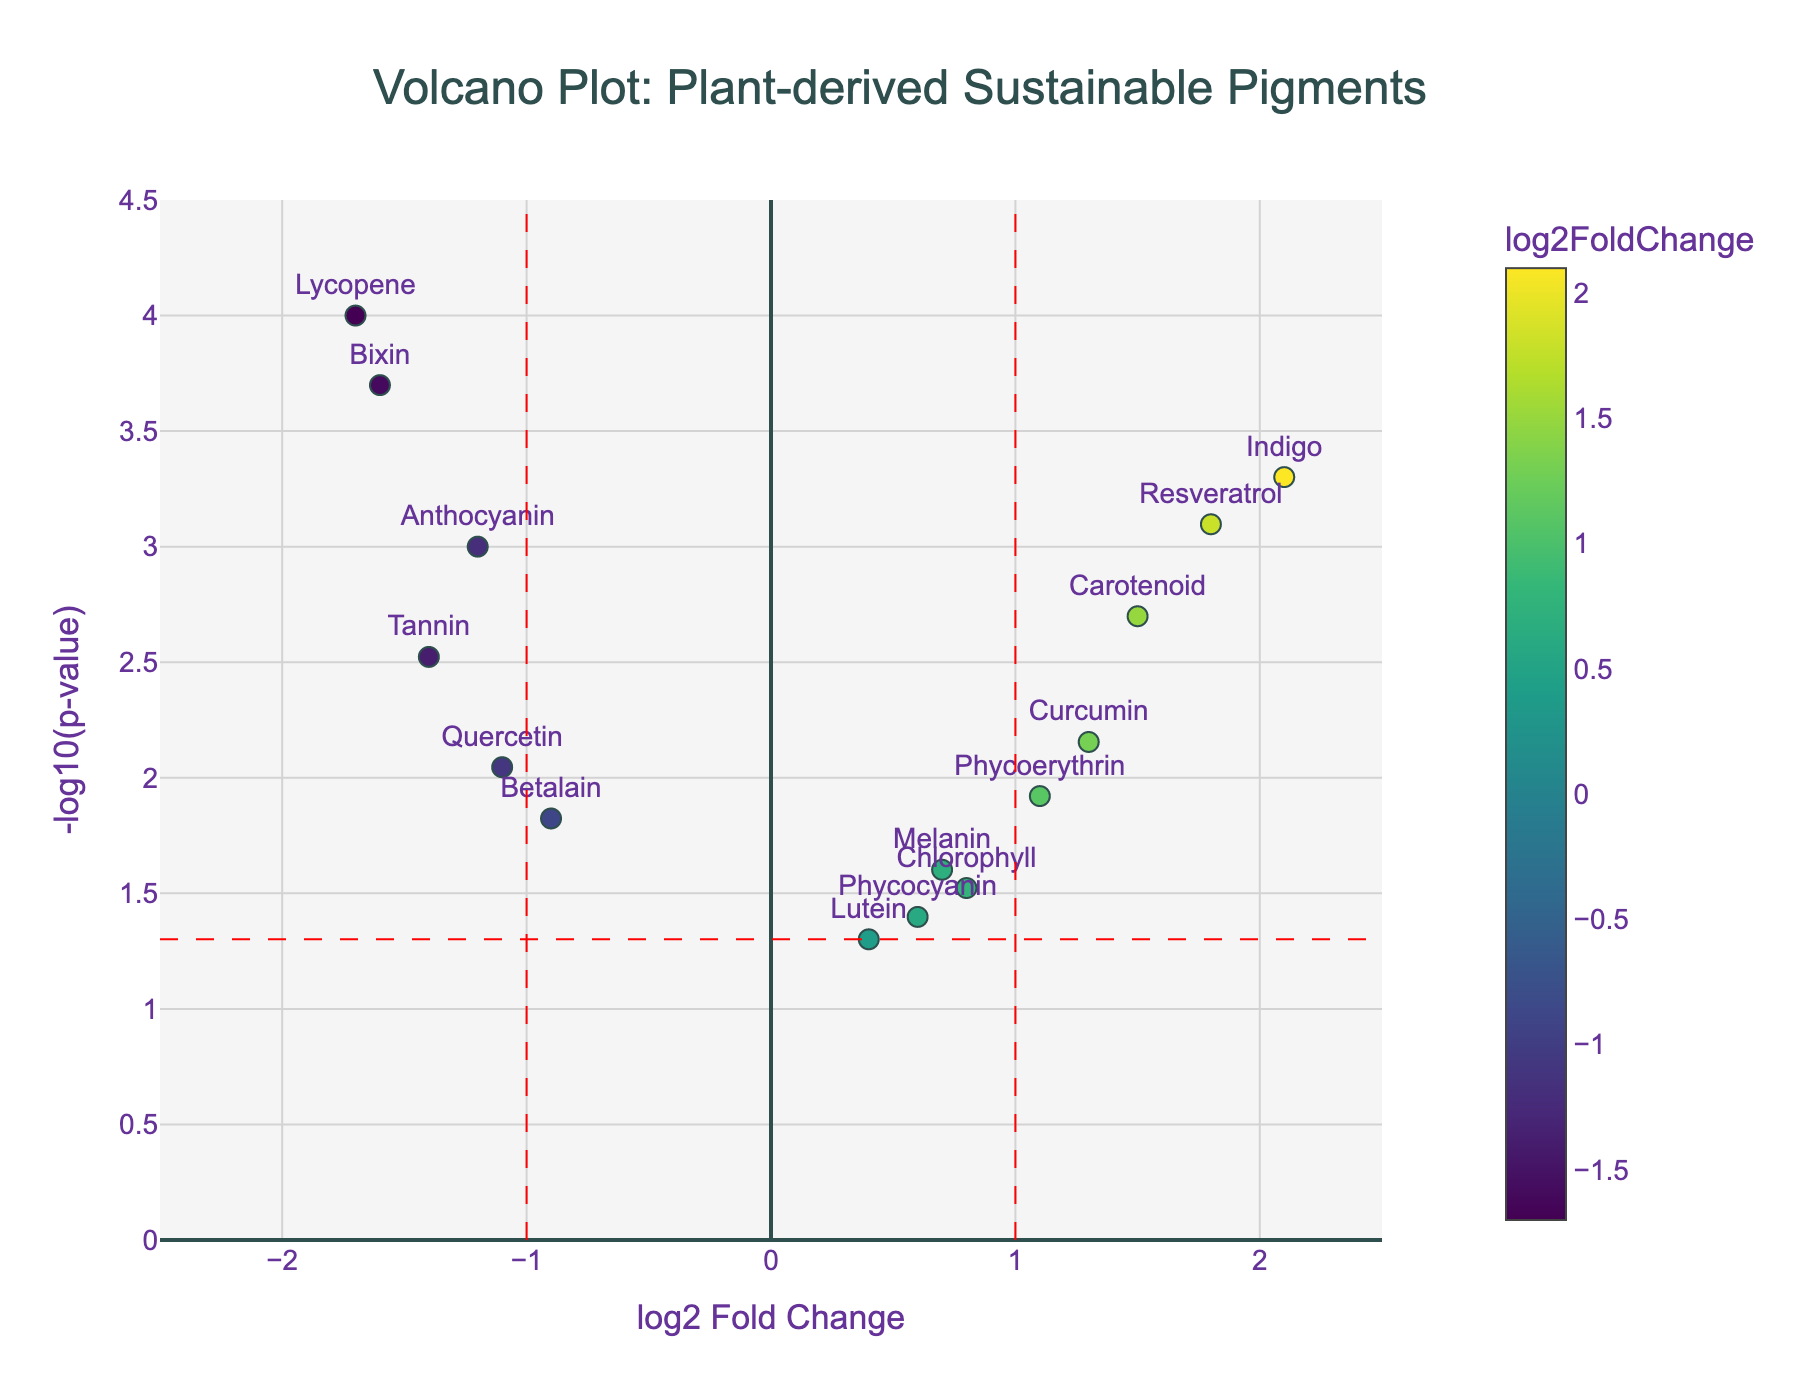What is the title of the volcano plot? The title can be found at the top of the plot. From the visual, it reads: "Volcano Plot: Plant-derived Sustainable Pigments"
Answer: Volcano Plot: Plant-derived Sustainable Pigments How many data points (genes) are represented on the plot? Each marker on the volcano plot represents a gene. By counting the markers, we can see there are 15 genes.
Answer: 15 What does the x-axis of the volcano plot represent? The x-axis label provides this information. It reads: "log2 Fold Change", which indicates the fold change of gene expression in logarithmic scale base 2.
Answer: log2 Fold Change What does the y-axis of the volcano plot represent? The y-axis label provides this information. It reads: "-log10(p-value)", which is the negative logarithm base 10 of the p-value.
Answer: -log10(p-value) Which gene shows the highest log2 fold change? By checking the x-axis values, the gene with the highest positive value is “Indigo” with a log2 fold change of 2.1.
Answer: Indigo Which gene has the lowest p-value? The gene with the highest -log10(p-value) on the y-axis has the lowest p-value. This gene is “Lycopene” with a p-value of 0.0001.
Answer: Lycopene How many genes have a significant p-value (< 0.05)? Genes below the horizontal red dashed line at y = -log10(0.05) are significant. Counting these, we find there are 12 significant genes.
Answer: 12 Which genes are considered down-regulated? Genes with negative log2 fold change are considered down-regulated. Examining the plot, these genes are Anthocyanin, Betalain, Quercetin, Lycopene, and Bixin.
Answer: Anthocyanin, Betalain, Quercetin, Lycopene, Bixin What color represents the highest log2 fold change? The plot uses a color gradient to represent log2 fold change, with the darkest color indicating the highest fold change. Indigo shows the highest, which correlates to dark green in the Viridis color scale used.
Answer: Dark green How many genes exceed a 2-fold change threshold (log2FC > 1 or log2FC < -1)? Genes outside the vertical red dashed lines at log2FC = -1 and log2FC = 1 meet this criterion. By counting, there are 8 genes: Anthocyanin, Carotenoid, Indigo, Lycopene, Resveratrol, Tannin, Phycoerythrin, and Bixin.
Answer: 8 